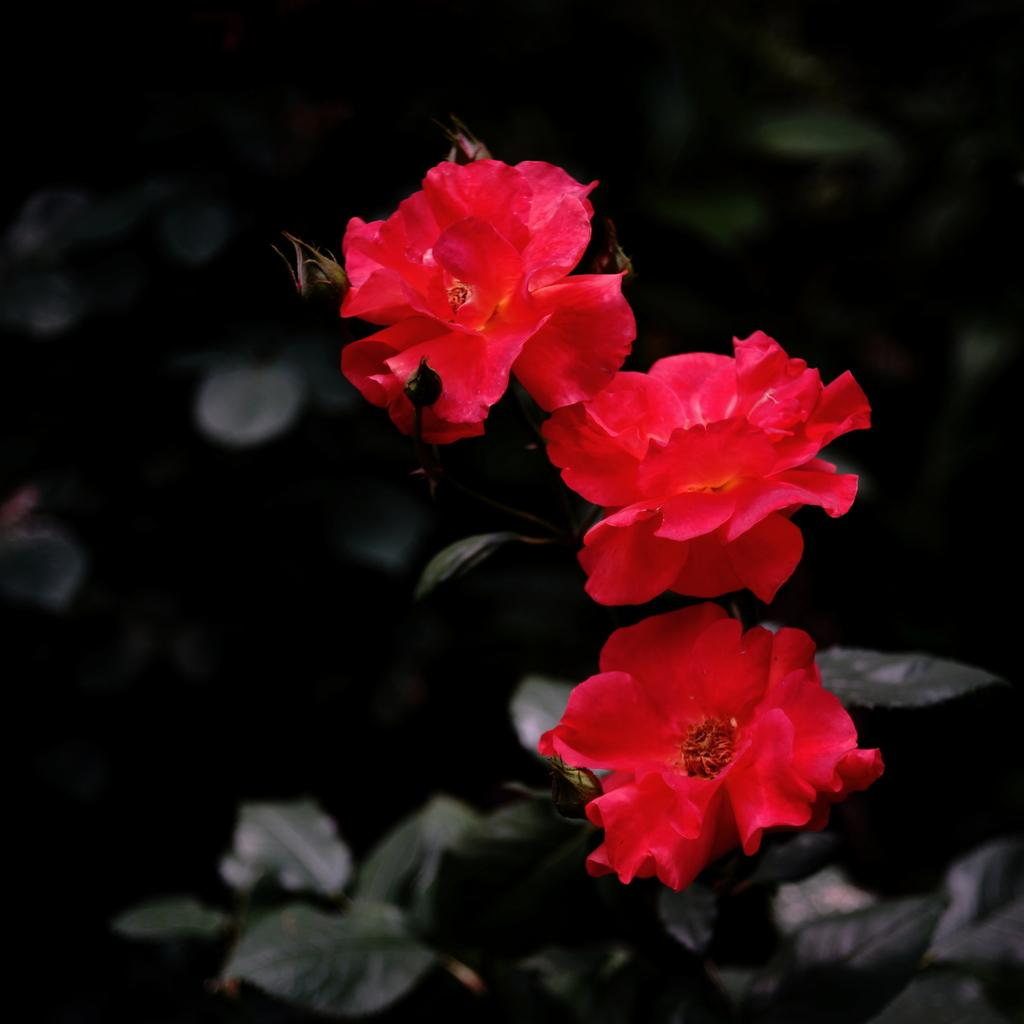What type of flowers are in the middle of the image? There are three red flowers in the middle of the image. What else can be seen in the background of the image? There are leaves in the background of the image. What type of meat is being used to water the flowers in the image? There is no meat present in the image, and the flowers are not being watered. 